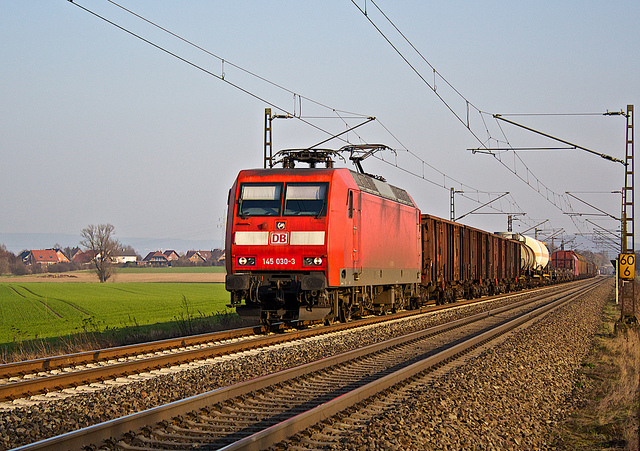Read all the text in this image. DB 148 030 60 6 3 